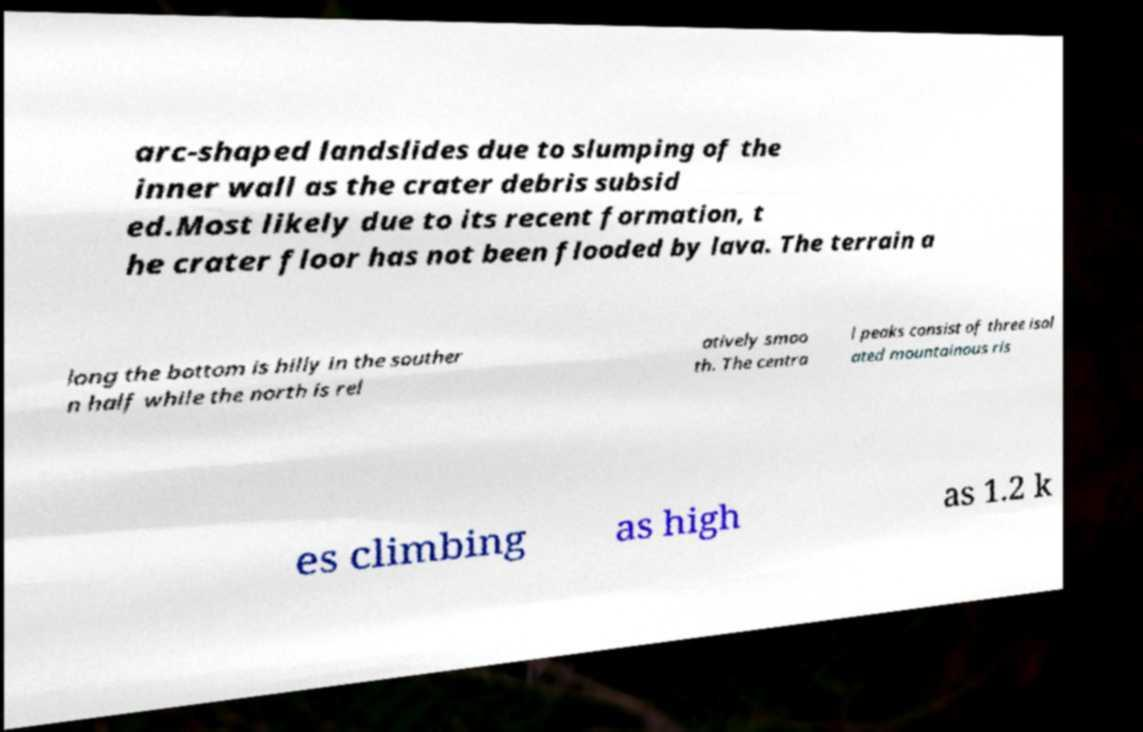Could you extract and type out the text from this image? arc-shaped landslides due to slumping of the inner wall as the crater debris subsid ed.Most likely due to its recent formation, t he crater floor has not been flooded by lava. The terrain a long the bottom is hilly in the souther n half while the north is rel atively smoo th. The centra l peaks consist of three isol ated mountainous ris es climbing as high as 1.2 k 